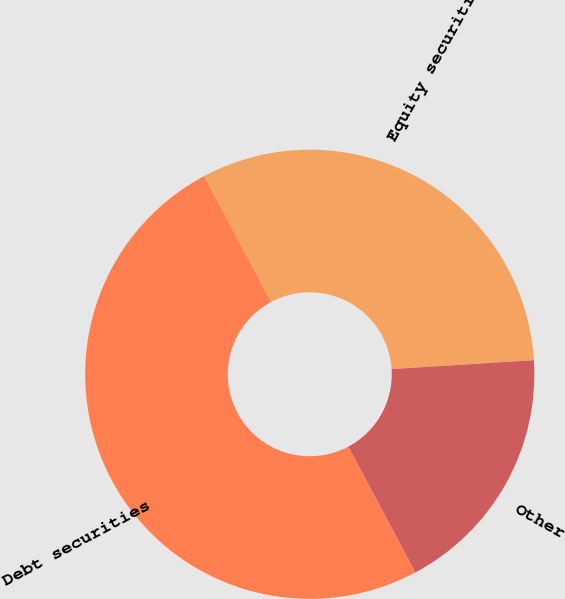<chart> <loc_0><loc_0><loc_500><loc_500><pie_chart><fcel>Equity securities<fcel>Debt securities<fcel>Other<nl><fcel>31.8%<fcel>50.0%<fcel>18.2%<nl></chart> 